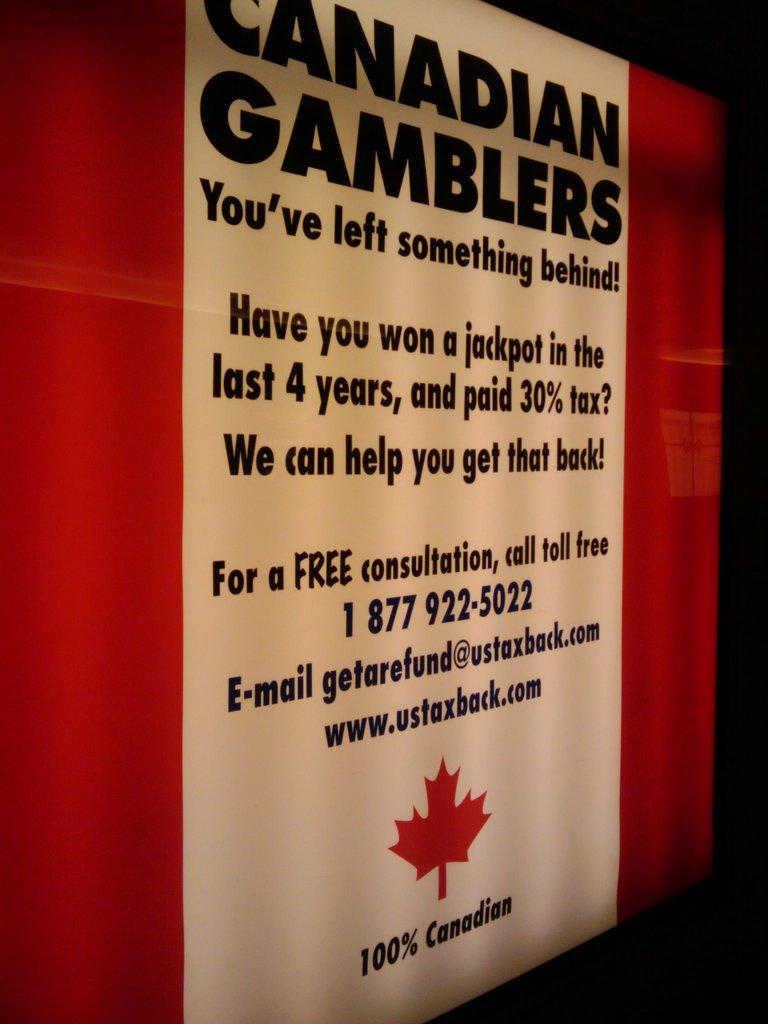Is this in canada?
Give a very brief answer. Yes. What phone number is listed?
Your response must be concise. 1 877 922-5022. 